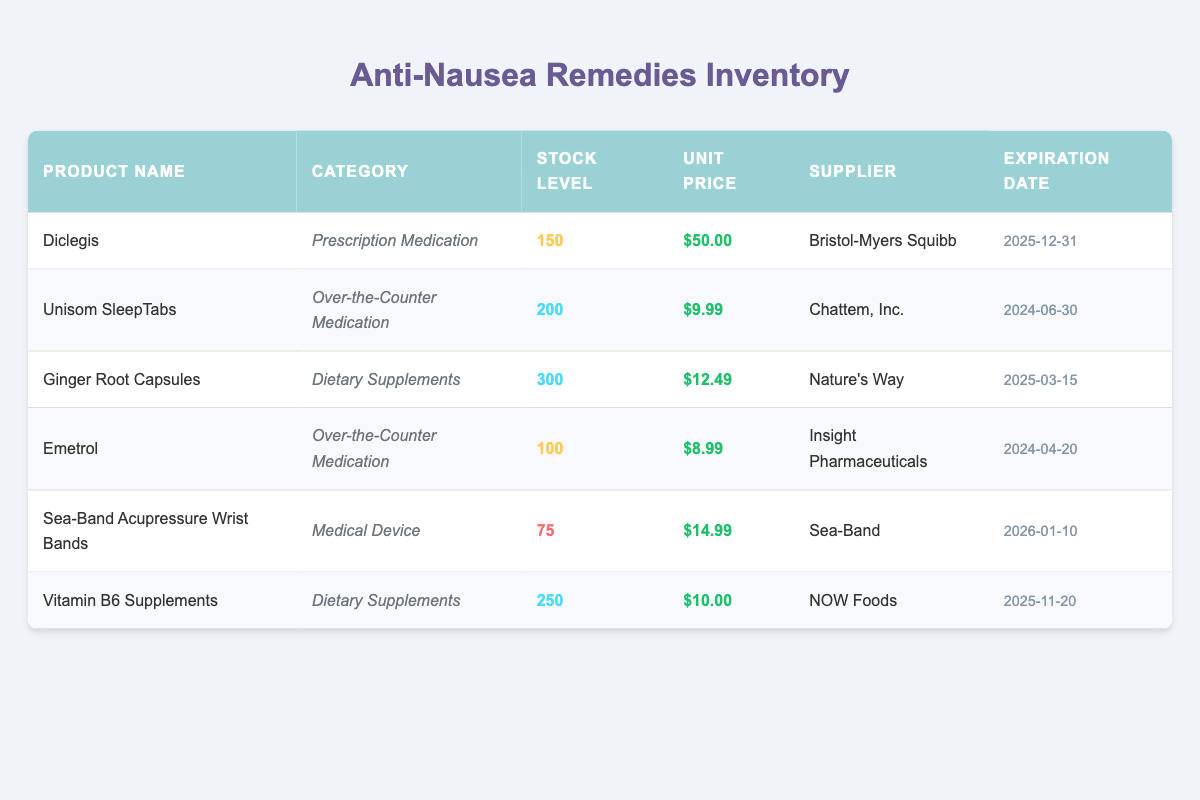What is the stock level of Diclegis? The stock level for Diclegis can be found in the table under the "Stock Level" column corresponding to Diclegis in the "Product Name" row. It is listed as 150.
Answer: 150 What is the unit price of Unisom SleepTabs? You can find the unit price of Unisom SleepTabs by locating the row for Unisom SleepTabs and looking at the "Unit Price" column. It is priced at 9.99.
Answer: 9.99 Are there more than 200 units of Ginger Root Capsules in stock? By checking the stock level listed for Ginger Root Capsules in the "Stock Level" column, which shows it as 300, we can confirm there are indeed more than 200 units.
Answer: Yes What is the total stock level of all dietary supplements? First, identify the dietary supplements from the table, which are Ginger Root Capsules (300) and Vitamin B6 Supplements (250). Then, sum their stock levels: 300 + 250 = 550.
Answer: 550 Does Emetrol have a larger stock level than Sea-Band Acupressure Wrist Bands? The stock level for Emetrol is 100 and for Sea-Band Acupressure Wrist Bands is 75. Since 100 is greater than 75, we can conclude that Emetrol has a larger stock level.
Answer: Yes What is the average unit price of all over-the-counter medications? The over-the-counter medications listed are Unisom SleepTabs (9.99) and Emetrol (8.99). We sum their prices: 9.99 + 8.99 = 18.98, then divide by 2 (the number of items) to find the average: 18.98 / 2 = 9.49.
Answer: 9.49 How many suppliers are listed for the products? By scanning the "Supplier" column, we see 5 unique suppliers: Bristol-Myers Squibb, Chattem, Inc., Nature’s Way, Insight Pharmaceuticals, and NOW Foods. Therefore, there are 5 different suppliers.
Answer: 5 Is the expiration date of Ginger Root Capsules later than that of Diclegis? The expiration date for Ginger Root Capsules is 2025-03-15 and for Diclegis is 2025-12-31. Since March comes before December, we conclude that the expiration date of Ginger Root Capsules is not later than that of Diclegis.
Answer: No 